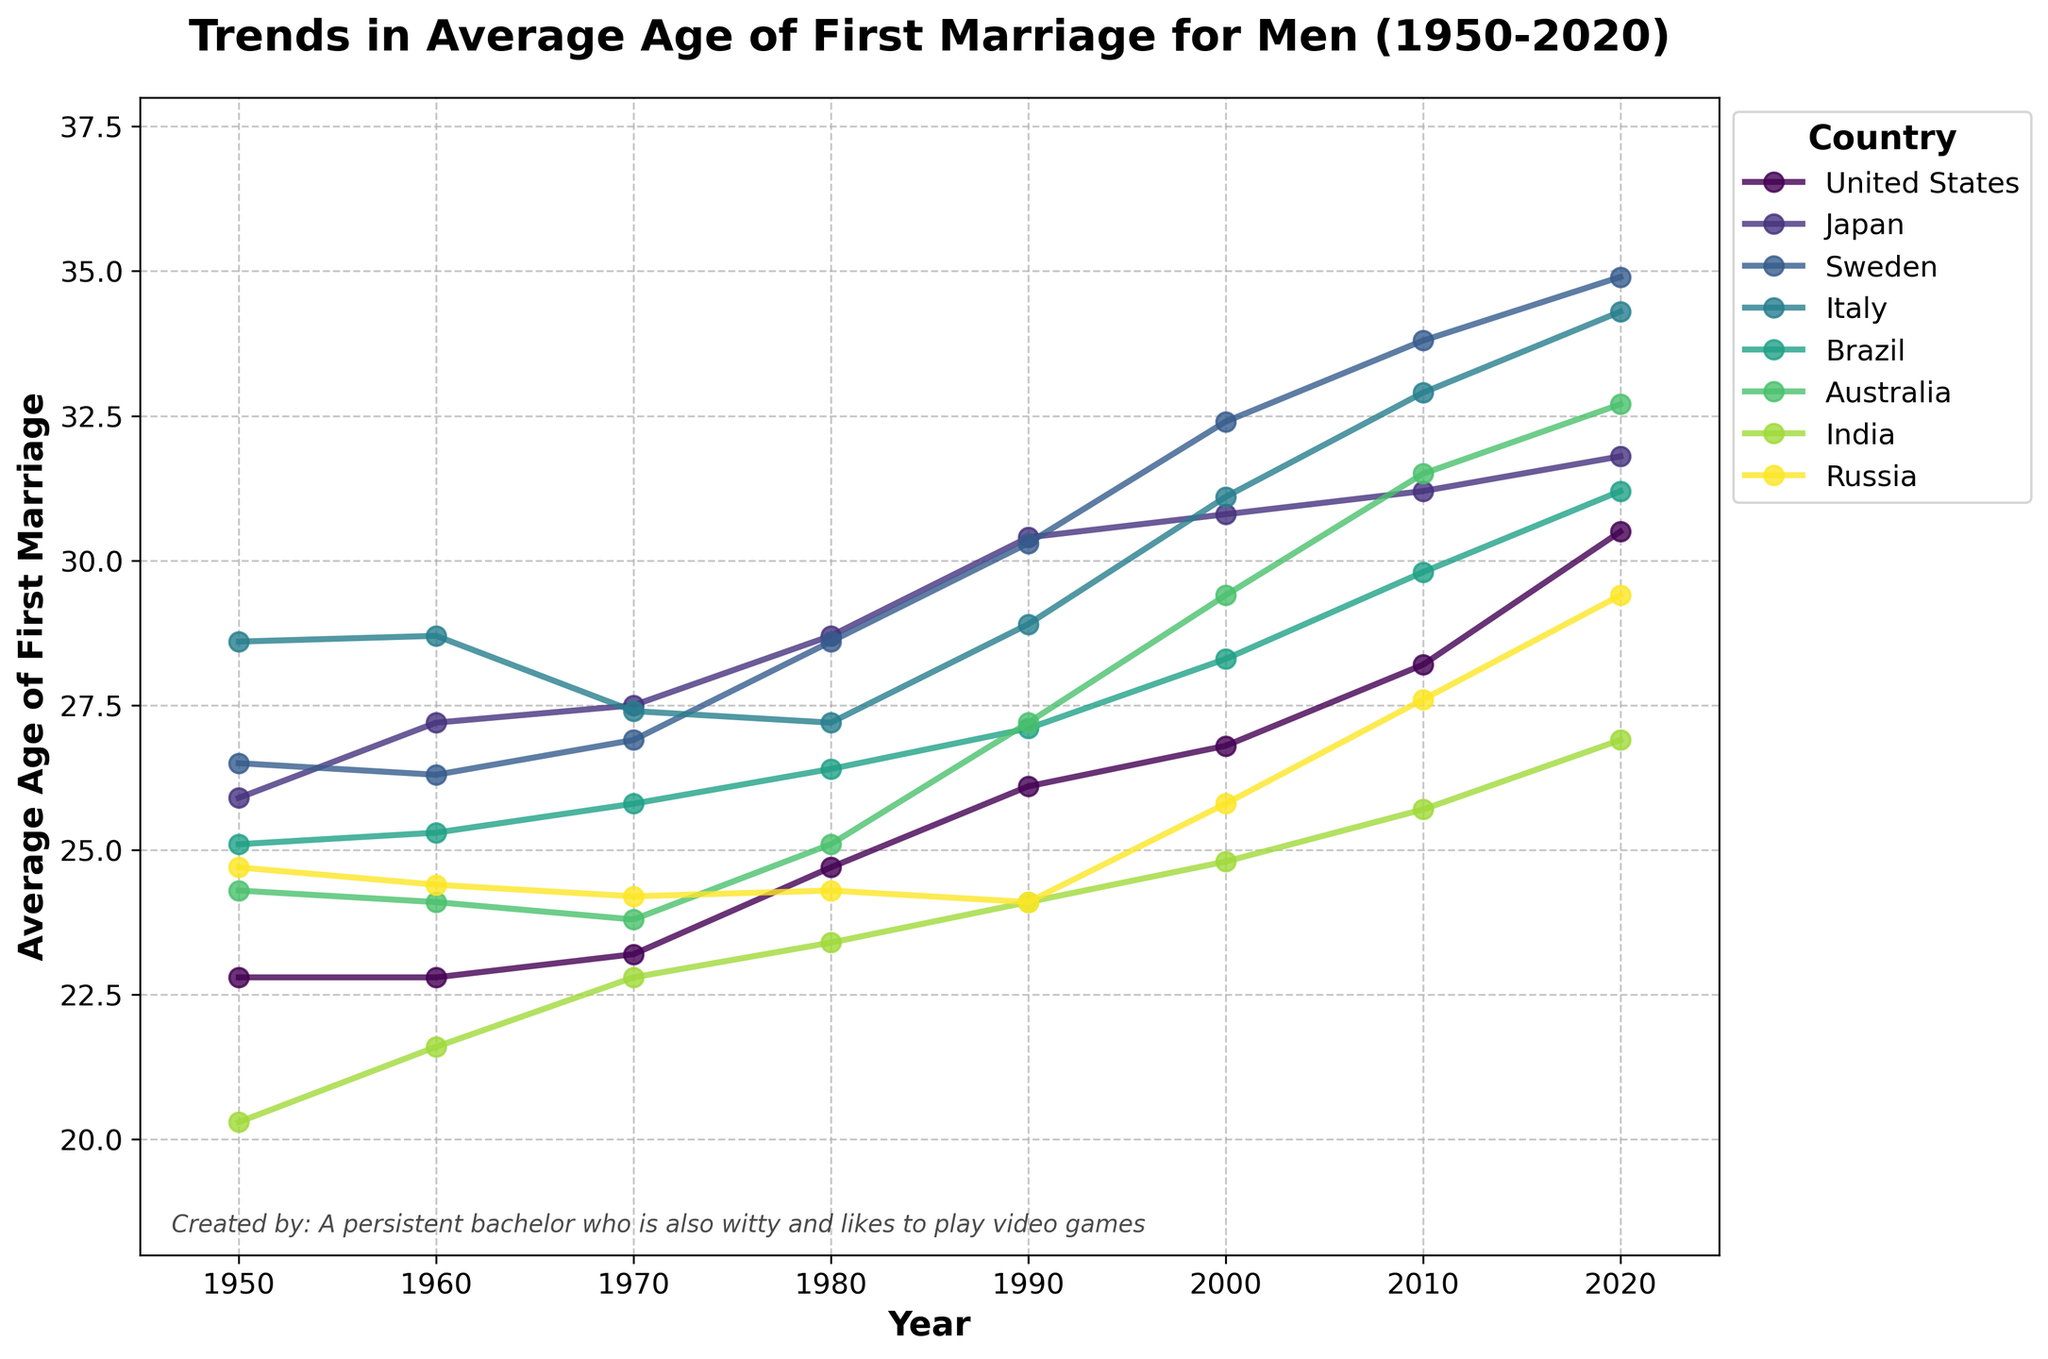Which country had the highest average age of first marriage in 2020? Find the values for each country in the year 2020 and compare them. The highest age in 2020 is 34.9 in Sweden.
Answer: Sweden Which country experienced the largest increase in average age of first marriage between 1950 and 2020? Calculate the difference in the average age of first marriage between 1950 and 2020 for each country. The largest difference is 8.4 years in Sweden (34.9 - 26.5 = 8.4).
Answer: Sweden What is the average age of first marriage for men in the United States and Japan in 1980? Check the data for the United States and Japan in the year 1980. The values are 24.7 for the United States and 28.7 for Japan. The average is (24.7 + 28.7) / 2 = 26.7.
Answer: 26.7 Which country had a lower average age of first marriage in 2000, Brazil or India? Compare the values for Brazil and India in 2000. Brazil's value is 28.3 and India's value is 24.8; thus, India had a lower average age of first marriage.
Answer: India By how many years did the average age of first marriage in Australia increase from 1970 to 2000? Calculate the difference between the ages in 1970 and 2000 for Australia. The values are 23.8 in 1970 and 29.4 in 2000. The difference is 29.4 - 23.8 = 5.6 years.
Answer: 5.6 Which country had the smallest change in average age of first marriage between 1950 and 2020? Calculate the difference in the average age of first marriage between 1950 and 2020 for each country. The smallest difference is for India: 26.9 - 20.3 = 6.6 years.
Answer: India What was the trend in the average age of first marriage for men in Russia from 1950 to 2020? Observe the data points for Russia over the years. The trend slightly decreased from 24.7 in 1950 to 24.1 in 1990, then increased to 29.4 by 2020.
Answer: Varied: Decreased then increased In which decade did men in Italy see the most significant decrease in the average age of first marriage? Identify the decade where the value dropped the most. The largest decrease occurs between 1960 and 1970 (28.7 to 27.4), a difference of 1.3 years.
Answer: 1960-1970 Which country's average age of first marriage was closest to a straight upward trend from 1950 to 2020? Visually examine the trend lines for each country to identify the most linear increase. Japan's line consistently increases without any significant dips or plateaus.
Answer: Japan 